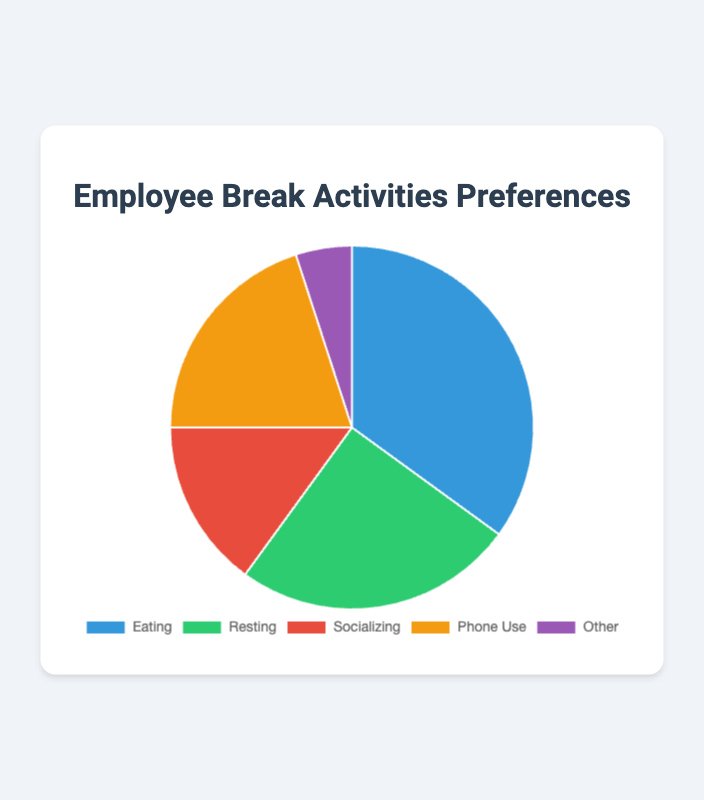What percentage of employees prefer socializing during breaks? The pie chart shows different segments for break activities, each labeled with a percentage. The segment labeled "Socializing" is shown to be 15%.
Answer: 15% Which activity do the most employees prefer during their breaks? The pie chart indicates that the largest segment, representing 35%, is labeled "Eating". Therefore, the most employees prefer eating during their breaks.
Answer: Eating How much more popular is eating compared to using the phone? Eating is represented by 35%, and phone use is 20%. The difference is calculated as 35% - 20% = 15%.
Answer: 15% What activities together make up over half of the employee preferences? Adding together the percentages for Eating (35%) and Resting (25%) gives 60%. Since this sum is greater than 50%, these two activities combined make up over half of the preferences.
Answer: Eating and Resting Is resting more common than socializing, and by how much? The pie chart shows 25% for resting and 15% for socializing. The difference is calculated as 25% - 15% = 10%. Therefore, resting is 10% more common than socializing.
Answer: Yes, by 10% What is the combined percentage for activities excluding Eating? Adding the percentages for Resting (25%), Socializing (15%), Phone Use (20%), and Other (5%) results in 25% + 15% + 20% + 5% = 65%.
Answer: 65% What activities together make up less than a quarter of the employee preferences? The "Other" activity is 5%. Adding "Socializing" which is 15%, gives 5% + 15% = 20%. Since this total is less than 25%, these two activities combined make up less than a quarter of the preferences.
Answer: Socializing and Other Which color represents the activity with the lowest preference? The smallest segment, labeled "Other", represents 5%. This segment is colored in purple.
Answer: Purple How much more popular is phone use compared to other activities labeled "Other"? Phone use is represented by 20%, while Other is 5%. The difference is calculated as 20% - 5% = 15%.
Answer: 15% Which activity has the second highest preference among employees? The pie chart shows that Resting has the second highest percentage at 25%. The highest preference is Eating at 35%, so Resting is second.
Answer: Resting 